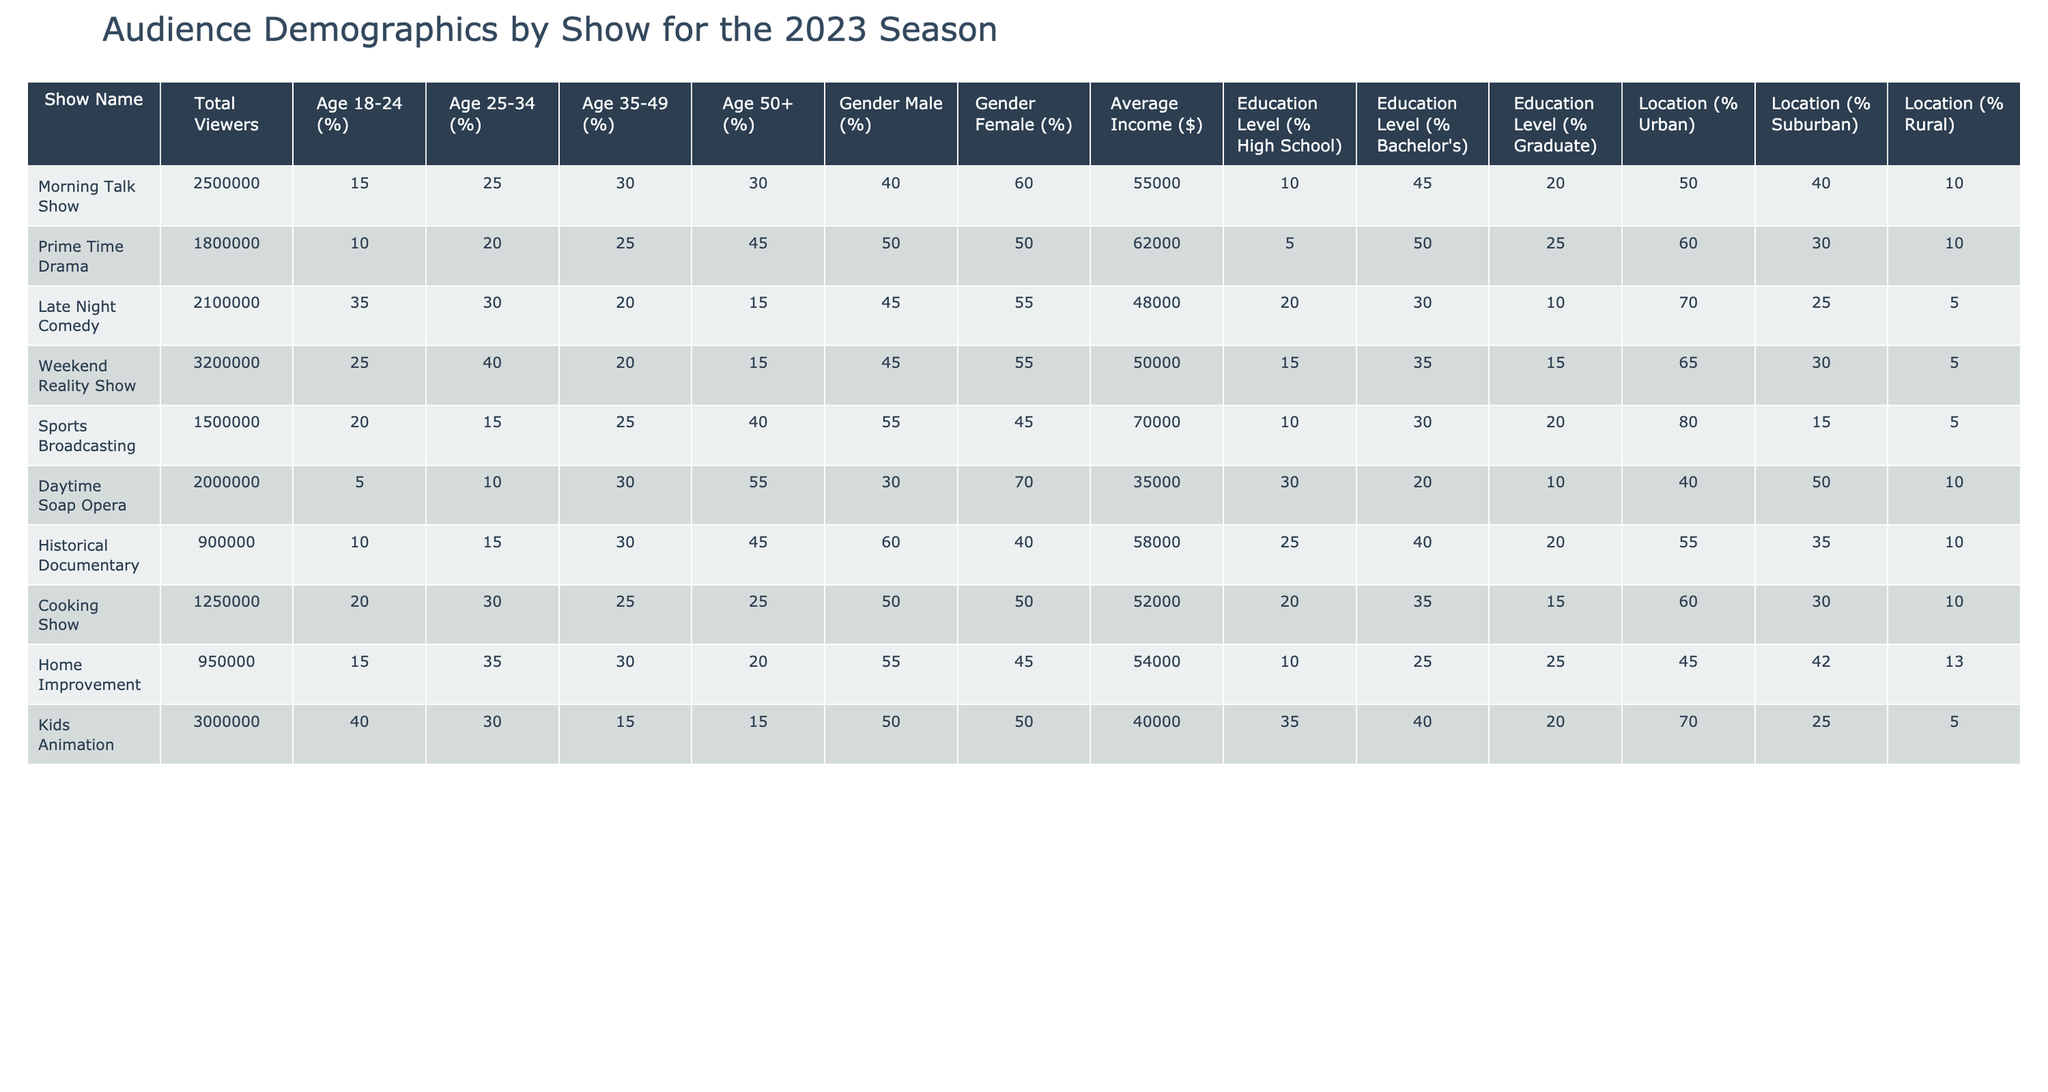What is the total number of viewers for the Morning Talk Show? The table shows that the "Total Viewers" for the Morning Talk Show is listed as 2,500,000.
Answer: 2,500,000 Which show has the highest percentage of viewers aged 18-24? Looking at the "Age 18-24 (%)" column, the Kids Animation show has the highest percentage at 40%.
Answer: Kids Animation What is the average income for viewers of the Prime Time Drama? The "Average Income ($)" column indicates that the average income for Prime Time Drama viewers is $62,000.
Answer: $62,000 Do more than 50% of viewers of the Daytime Soap Opera have a Bachelor's degree? The "Education Level (% Bachelor's)" for the Daytime Soap Opera is 20%, which is less than 50%.
Answer: No Which show has the lowest percentage of viewers aged 50 and above? The "Age 50+ (%)" column shows that the Late Night Comedy has the lowest percentage of viewers aged 50 and above, which is 15%.
Answer: Late Night Comedy What percentage of viewers for the Weekend Reality Show are female? The "Gender Female (%)" for the Weekend Reality Show is listed as 55%.
Answer: 55% How many viewers does the Sports Broadcasting show have compared to the Cooking Show? The Sports Broadcasting show has 1,500,000 viewers, while the Cooking Show has 1,250,000 viewers. The difference is 1,500,000 - 1,250,000 = 250,000.
Answer: 250,000 more viewers Which show has a higher percentage of its audience living in urban areas, the Prime Time Drama or the Late Night Comedy? The "Location (% Urban)" for Prime Time Drama is 60% and for Late Night Comedy is 70%. Late Night Comedy has a higher percentage.
Answer: Late Night Comedy Is the average income of the viewers for the Cooking Show greater than that of the Daytime Soap Opera? The average income for the Cooking Show is $52,000, while it's $35,000 for the Daytime Soap Opera. Therefore, $52,000 is greater than $35,000.
Answer: Yes What is the total percentage of viewers aged 35-49 across all shows? Adding the percentages from the "Age 35-49 (%)" column gives: 30 + 25 + 20 + 20 + 25 + 30 + 30 + 25 + 15 = 250%.
Answer: 250% 